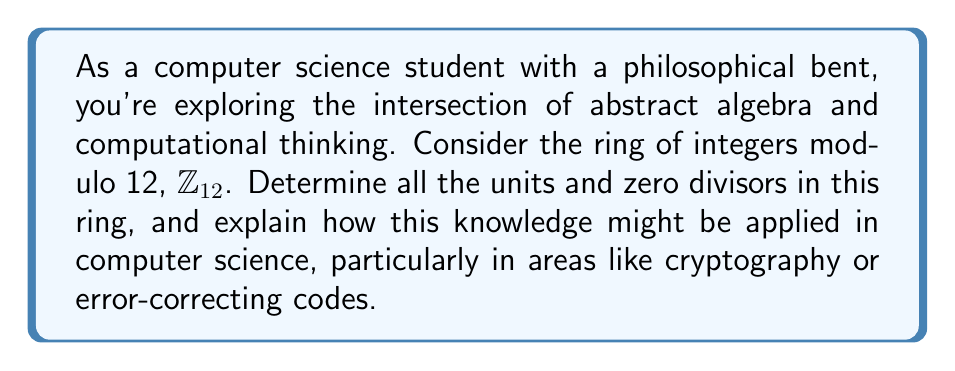Show me your answer to this math problem. Let's approach this step-by-step:

1) First, recall that in $\mathbb{Z}_{12}$, all elements are represented by the integers 0 to 11.

2) Units in a ring are elements that have multiplicative inverses. In $\mathbb{Z}_{12}$, an element $a$ is a unit if there exists a $b$ such that $ab \equiv 1 \pmod{12}$.

3) To find the units, we can check each element:
   
   $1 \cdot 1 \equiv 1 \pmod{12}$, so 1 is a unit
   $5 \cdot 5 \equiv 1 \pmod{12}$, so 5 is a unit
   $7 \cdot 7 \equiv 1 \pmod{12}$, so 7 is a unit
   $11 \cdot 11 \equiv 1 \pmod{12}$, so 11 is a unit

4) Zero divisors are non-zero elements $a$ such that there exists a non-zero $b$ where $ab \equiv 0 \pmod{12}$.

5) Checking each non-zero element:
   
   $2 \cdot 6 \equiv 0 \pmod{12}$, so 2 and 6 are zero divisors
   $3 \cdot 4 \equiv 0 \pmod{12}$, so 3 and 4 are zero divisors
   $8 \cdot 3 \equiv 0 \pmod{12}$, so 8 is a zero divisor
   $9 \cdot 4 \equiv 0 \pmod{12}$, so 9 is a zero divisor
   $10 \cdot 6 \equiv 0 \pmod{12}$, so 10 is a zero divisor

6) Application in Computer Science:

   In cryptography, the existence of units is crucial for certain algorithms. For instance, in RSA encryption, we work in a ring of integers modulo n, where n is the product of two large primes. The security of RSA relies on the fact that certain elements have multiplicative inverses (are units) in this ring.

   Zero divisors, on the other hand, can be problematic in certain contexts. In error-correcting codes, we often work with polynomial rings over finite fields. The presence of zero divisors in these rings can lead to non-unique factorizations, which can complicate the design of efficient coding schemes.

   Understanding the structure of rings like $\mathbb{Z}_{12}$ provides insights into these more complex systems used in practical applications.
Answer: Units in $\mathbb{Z}_{12}$: $\{1, 5, 7, 11\}$
Zero divisors in $\mathbb{Z}_{12}$: $\{2, 3, 4, 6, 8, 9, 10\}$ 